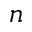<formula> <loc_0><loc_0><loc_500><loc_500>n</formula> 